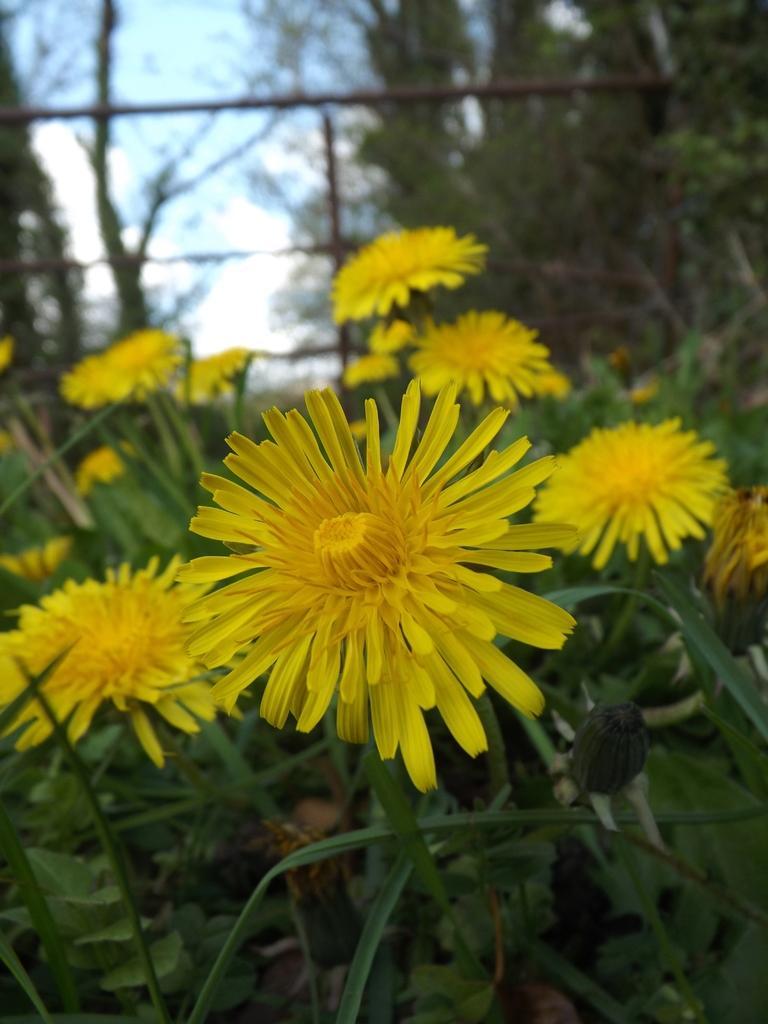Can you describe this image briefly? In this picture, we see the plants which have flowers and these flowers are in yellow color. In the background, we see the wooden sticks. There are trees in the background and we even see the sky. 